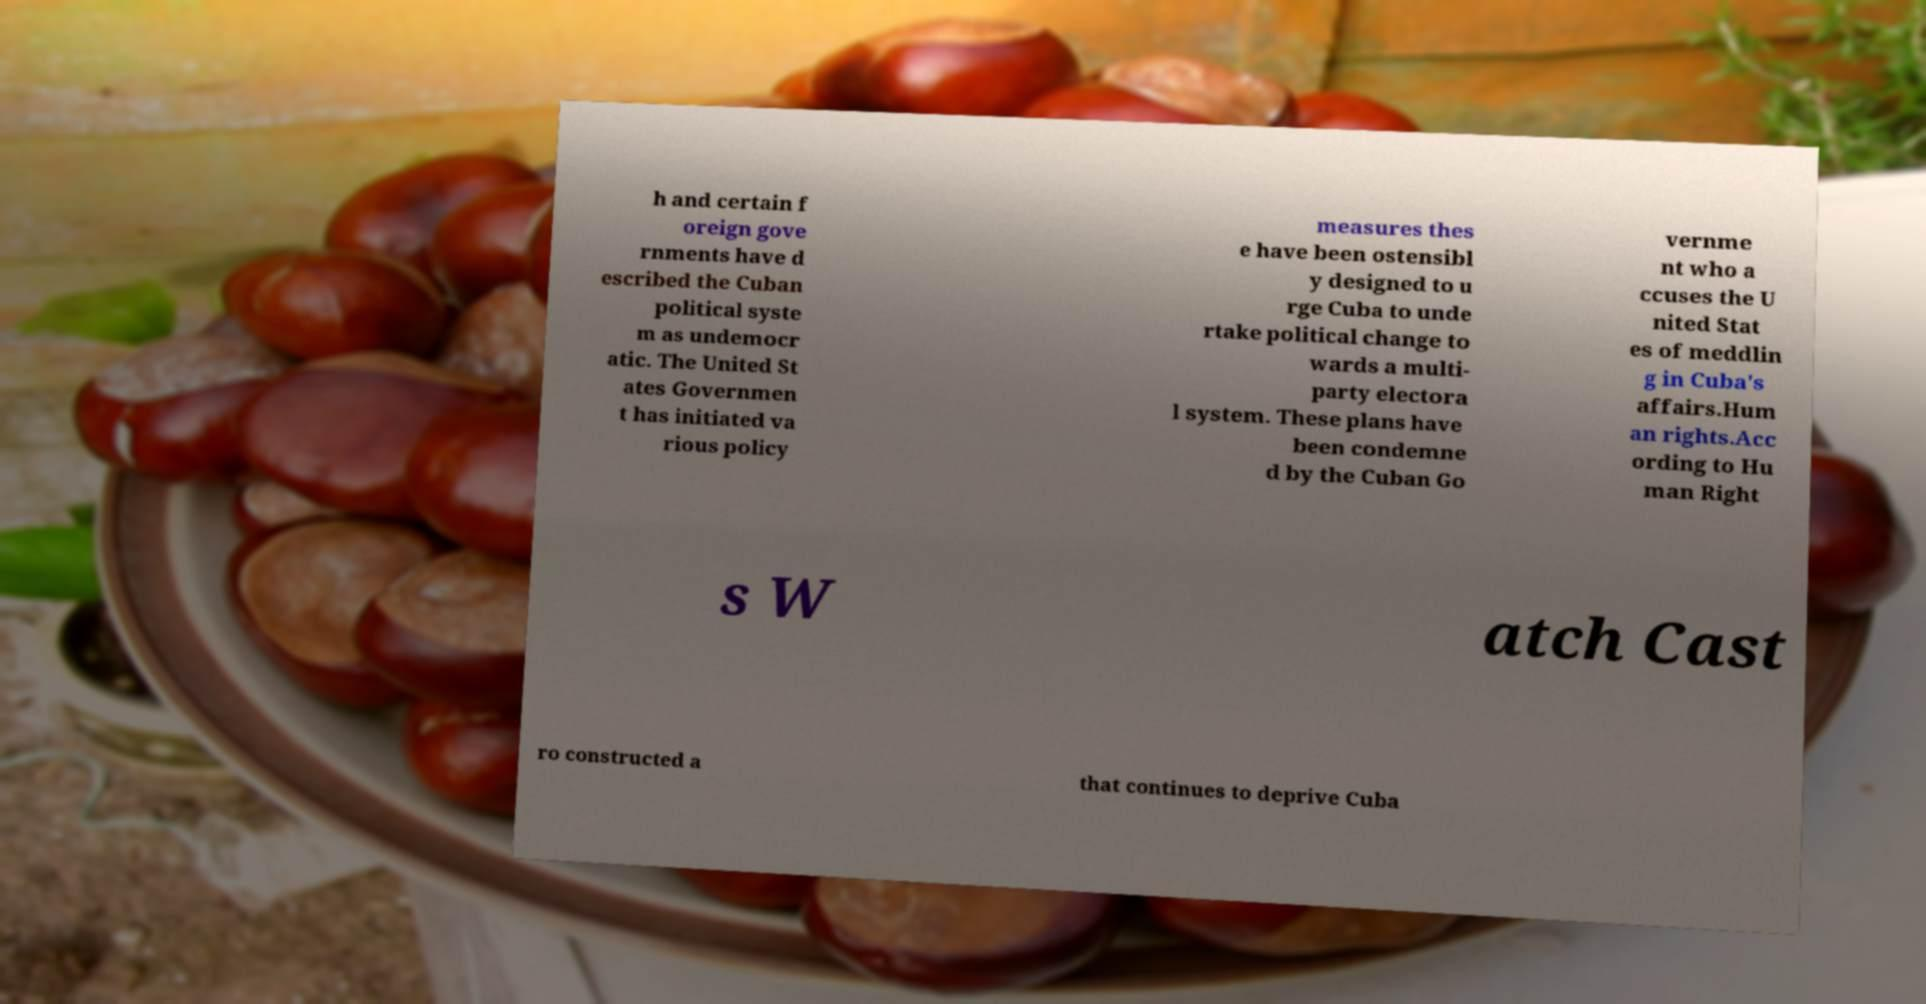Can you read and provide the text displayed in the image?This photo seems to have some interesting text. Can you extract and type it out for me? h and certain f oreign gove rnments have d escribed the Cuban political syste m as undemocr atic. The United St ates Governmen t has initiated va rious policy measures thes e have been ostensibl y designed to u rge Cuba to unde rtake political change to wards a multi- party electora l system. These plans have been condemne d by the Cuban Go vernme nt who a ccuses the U nited Stat es of meddlin g in Cuba's affairs.Hum an rights.Acc ording to Hu man Right s W atch Cast ro constructed a that continues to deprive Cuba 